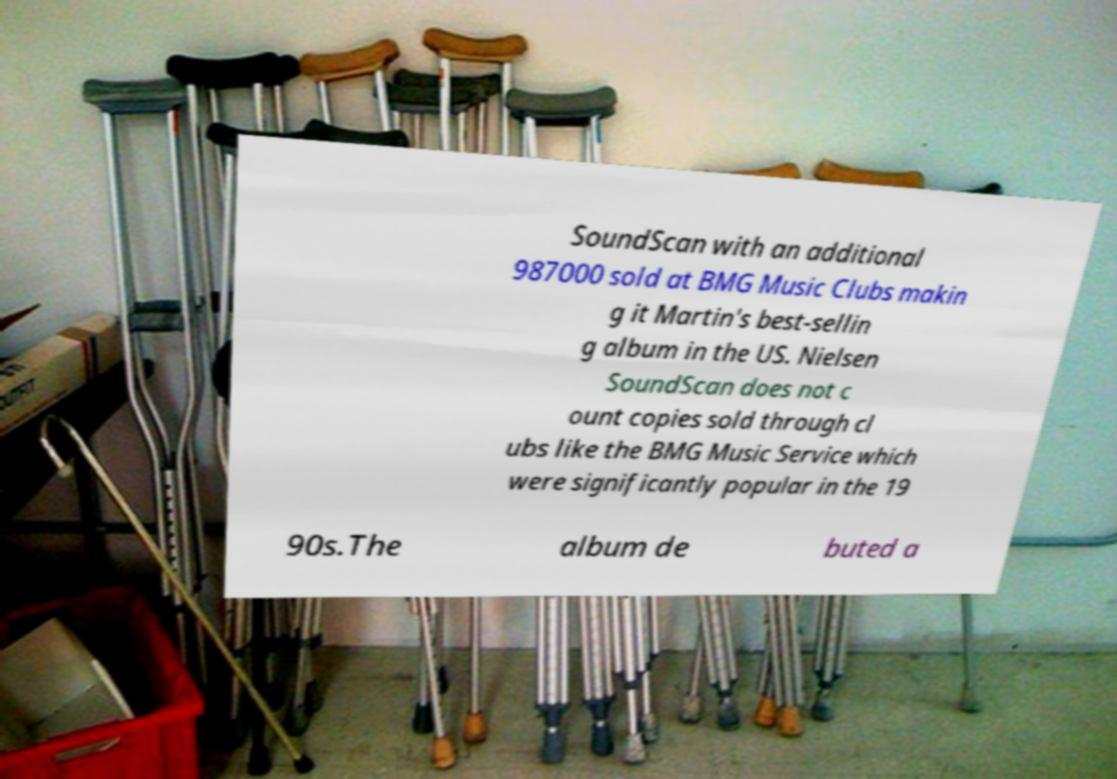Please identify and transcribe the text found in this image. SoundScan with an additional 987000 sold at BMG Music Clubs makin g it Martin's best-sellin g album in the US. Nielsen SoundScan does not c ount copies sold through cl ubs like the BMG Music Service which were significantly popular in the 19 90s.The album de buted a 